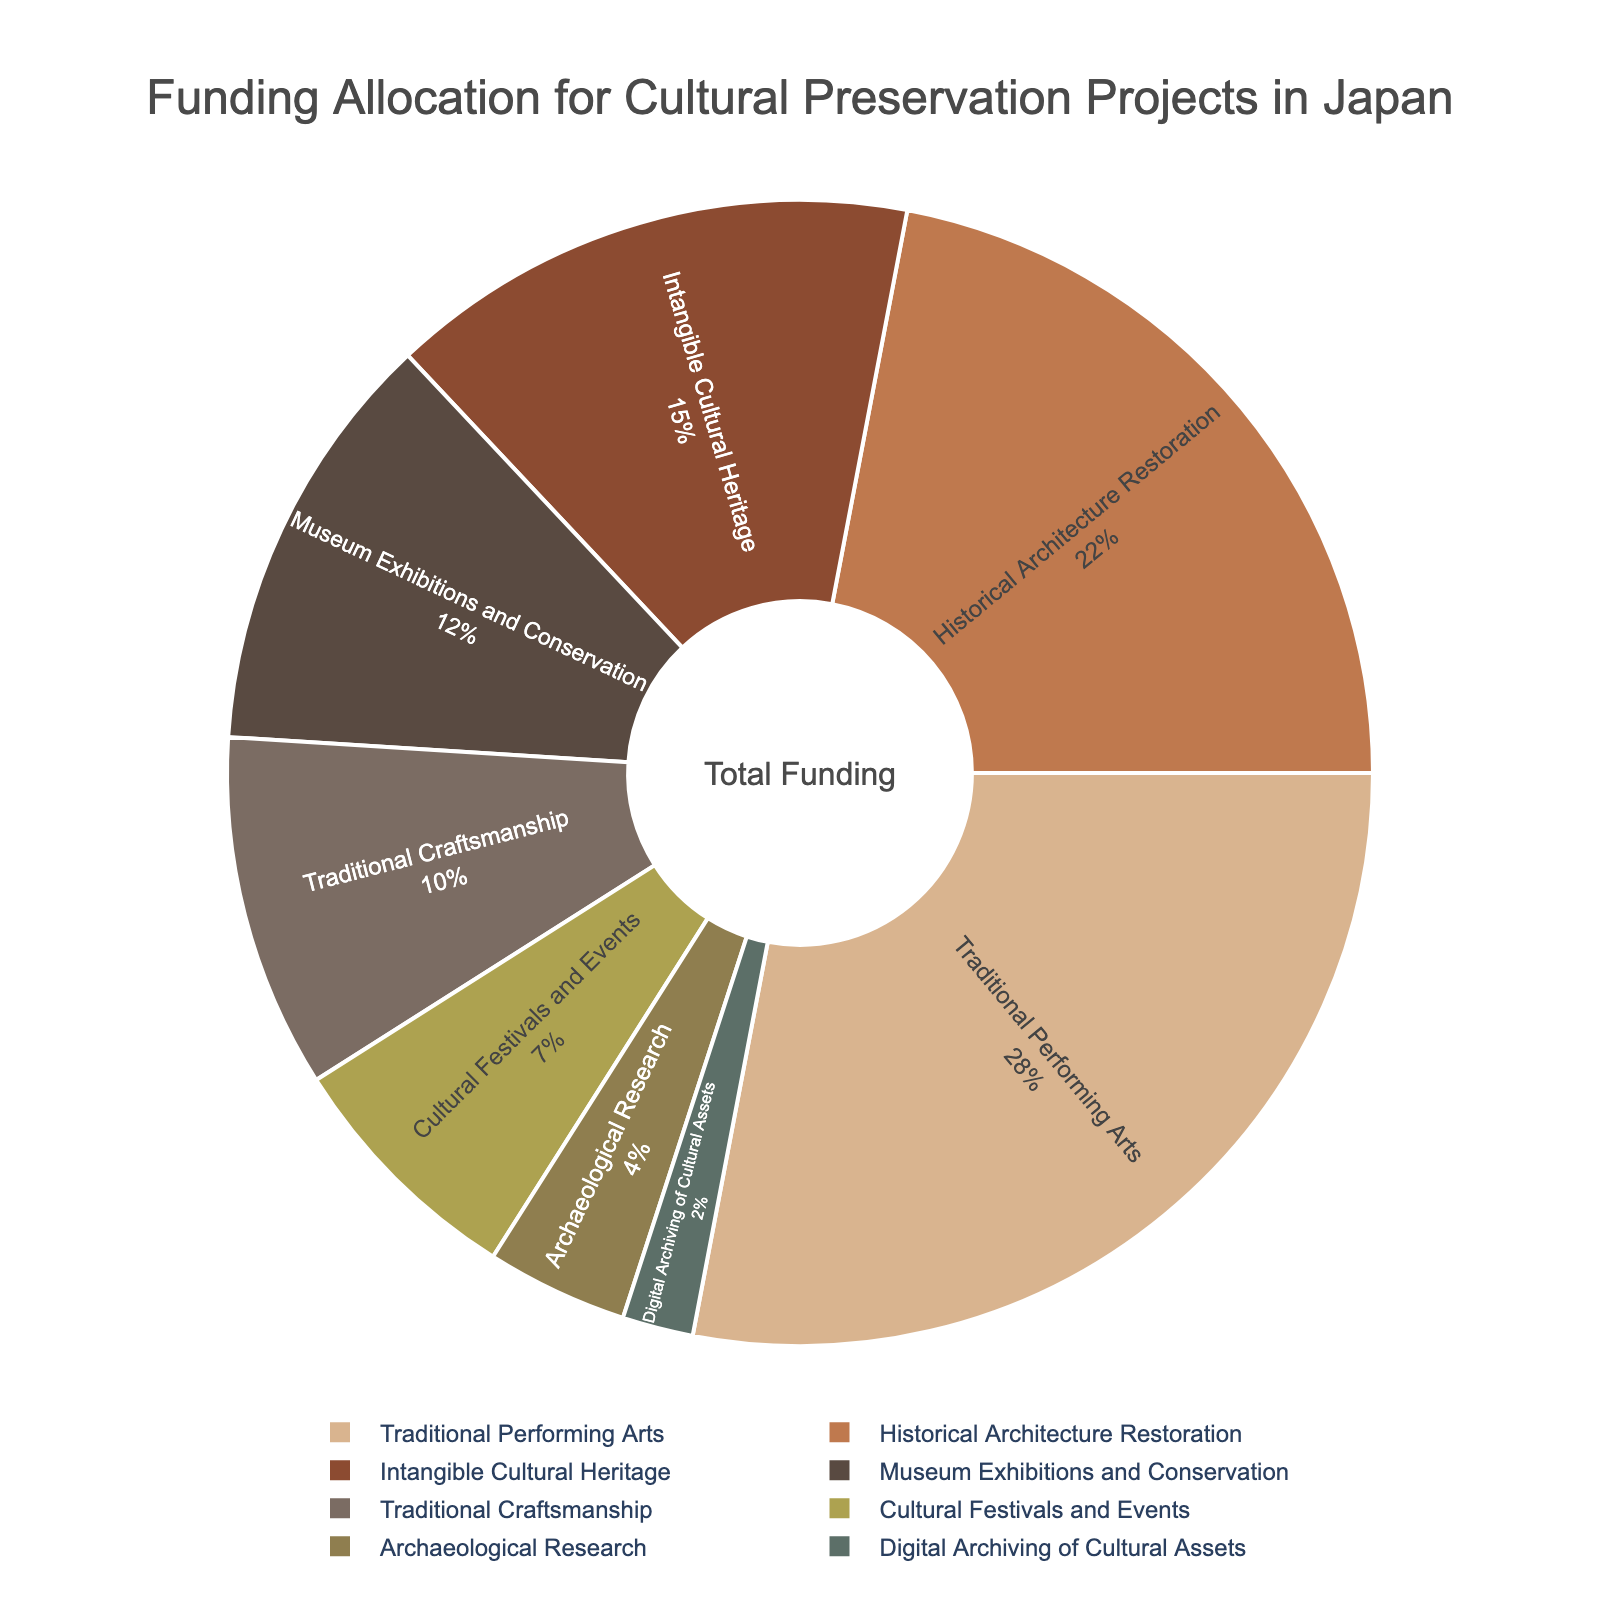Which category receives the highest percentage of funding? The pie chart shows different percentages for each category. By examining the chart, the largest portion is allocated to Traditional Performing Arts.
Answer: Traditional Performing Arts What is the total percentage allocation for Historical Architecture Restoration and Museum Exhibitions and Conservation combined? The allocation for Historical Architecture Restoration is 22% and for Museum Exhibitions and Conservation is 12%. Adding them together gives 22% + 12% = 34%.
Answer: 34% Compare the funding percentages for Traditional Craftsmanship and Archaeological Research. Which one gets more funding? Traditional Craftsmanship is allocated 10% and Archaeological Research is allocated 4%. 10% is greater than 4%.
Answer: Traditional Craftsmanship By how much does the percentage allocation for Intangible Cultural Heritage exceed that of Cultural Festivals and Events? Intangible Cultural Heritage is allocated 15% and Cultural Festivals and Events is allocated 7%. The difference is 15% - 7% = 8%.
Answer: 8% What is the average percentage funding for Traditional Craftsmanship, Cultural Festivals and Events, and Digital Archiving of Cultural Assets? Adding the percentages: 10% (Traditional Craftsmanship) + 7% (Cultural Festivals and Events) + 2% (Digital Archiving of Cultural Assets) = 19%. Dividing by the number of categories (3), the average is 19% / 3 ≈ 6.33%.
Answer: 6.33% How does the funding allocation for Digital Archiving of Cultural Assets compare with Intangible Cultural Heritage? Digital Archiving of Cultural Assets is allocated 2% and Intangible Cultural Heritage is allocated 15%. 2% is less than 15%.
Answer: Digital Archiving of Cultural Assets gets less funding What is the difference in funding allocations between Traditional Performing Arts and the category with the lowest funding? Traditional Performing Arts receives 28%, and the category with the lowest funding, Digital Archiving of Cultural Assets, gets 2%. The difference is 28% - 2% = 26%.
Answer: 26% 